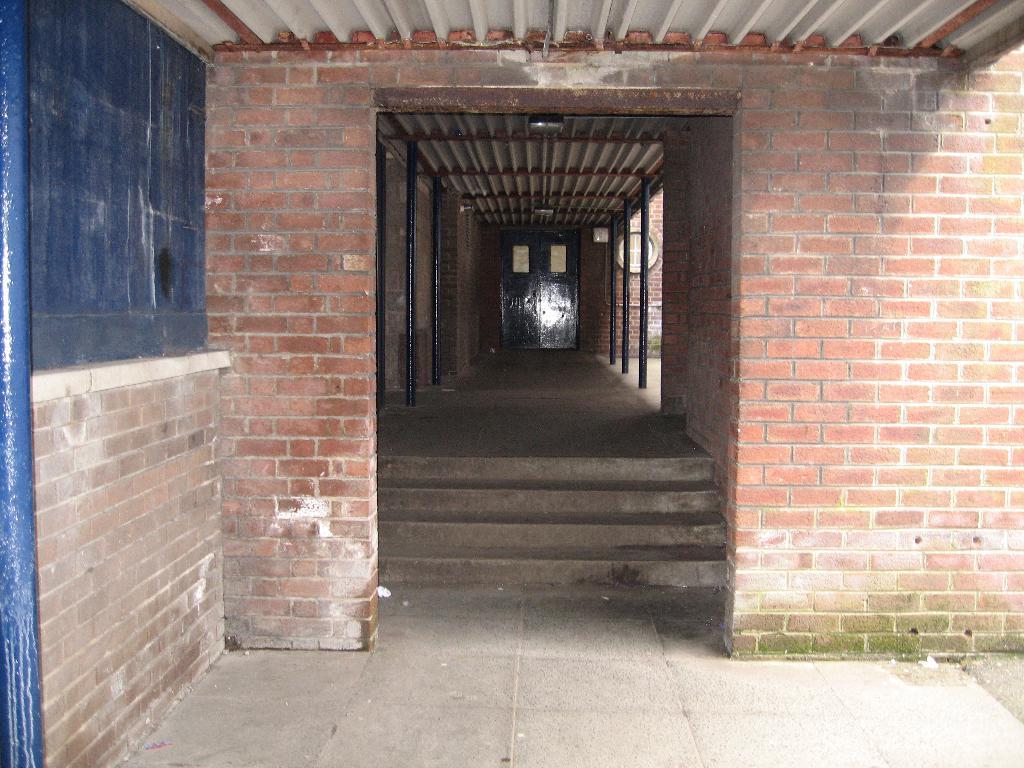Please provide a concise description of this image. On the left side, there is a board which is attached to the brick wall of a building which is having roof, steps, floor and poles. In the background, there is a door. 